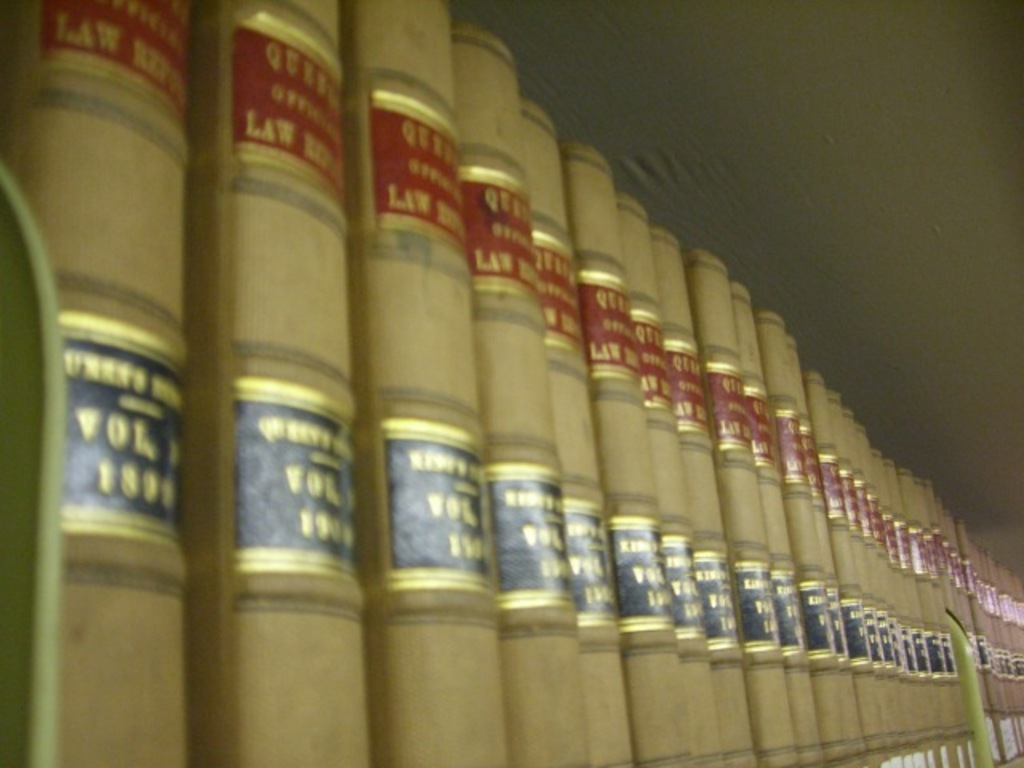Estimate how old these books might be and discuss their historical context. Given the style of binding and typography, these books appear to be from the mid to late 20th century. They represent a period in legal history when printed law books were indispensable to lawyers and judges, serving as the primary means of accessing legal precedents and statutes before the digital era. What impact do such collections have on the study of law today? Though modern legal practice increasingly relies on digital resources, collections like these remain vital for historical legal research and for understanding the evolution of law. They provide invaluable insights into the legal thinking of the past and help law students and scholars appreciate the foundations of current legal systems. 